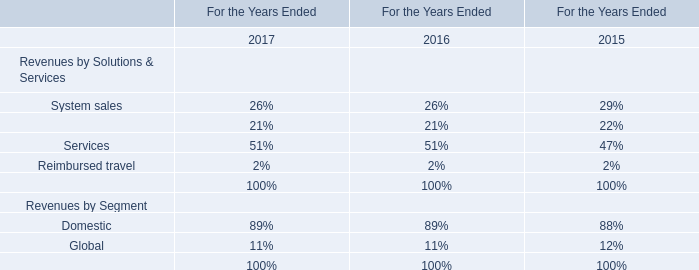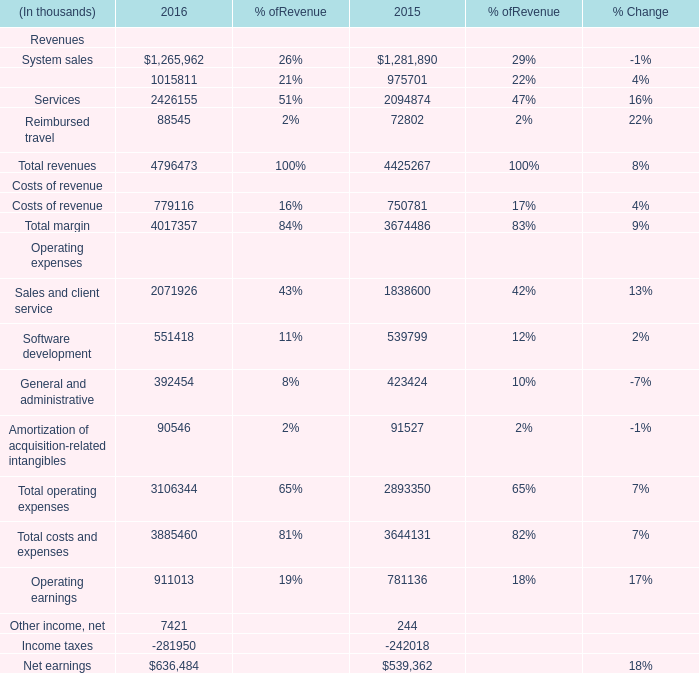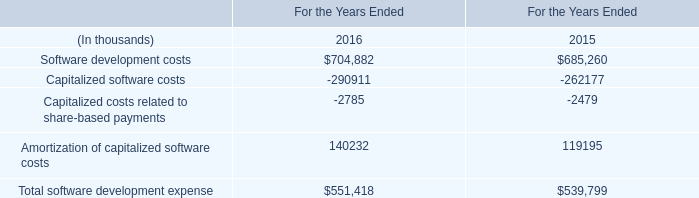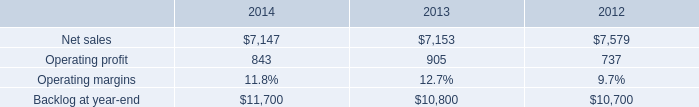What's the average of Support and maintenance of 2016, and Capitalized software costs of For the Years Ended 2016 ? 
Computations: ((1015811.0 + 290911.0) / 2)
Answer: 653361.0. 